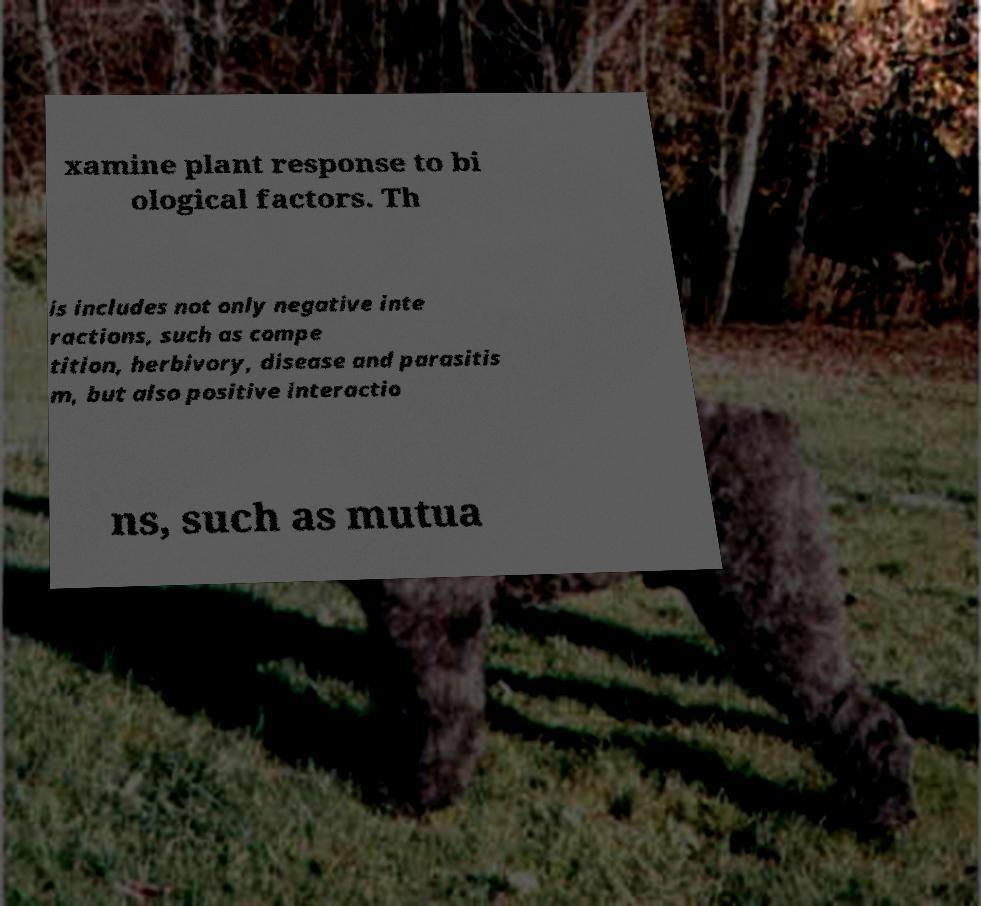Could you extract and type out the text from this image? xamine plant response to bi ological factors. Th is includes not only negative inte ractions, such as compe tition, herbivory, disease and parasitis m, but also positive interactio ns, such as mutua 